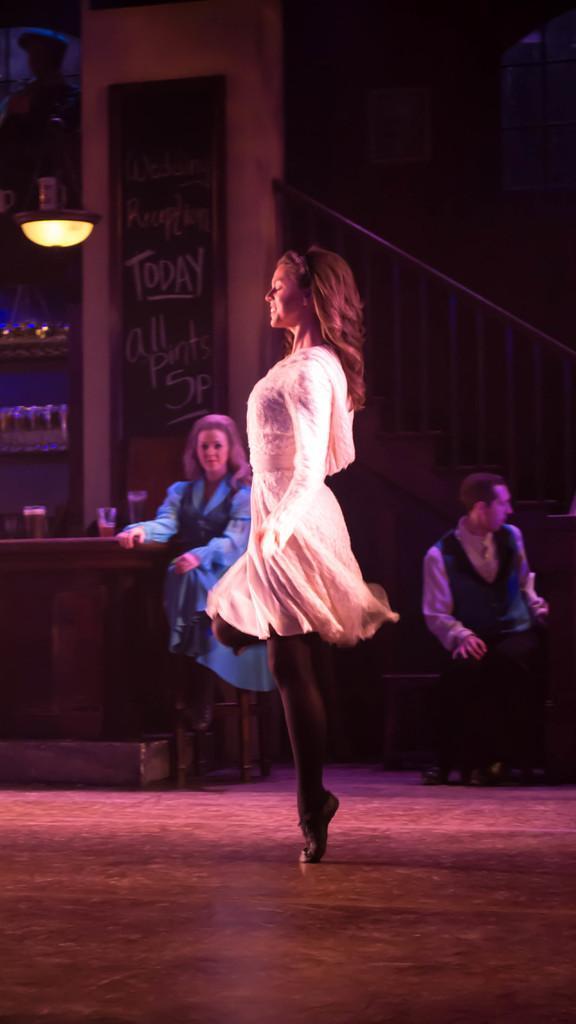Could you give a brief overview of what you see in this image? In this image we can see three persons, among them two persons are sitting and one person is standing, there is a table, on the table, we can see some glasses with liquids, also we can see the grille, some shelves with objects and a board with some text on it. 